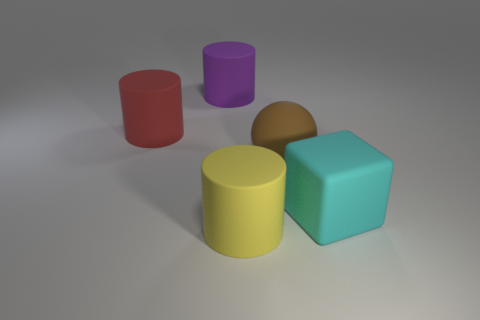The large thing that is on the right side of the large purple rubber cylinder and on the left side of the large brown rubber ball has what shape?
Make the answer very short. Cylinder. What number of large cyan blocks have the same material as the brown ball?
Make the answer very short. 1. Are there fewer things that are right of the sphere than big purple objects that are on the right side of the block?
Provide a succinct answer. No. There is a cylinder that is to the right of the rubber cylinder that is behind the red cylinder behind the cyan rubber block; what is it made of?
Your response must be concise. Rubber. There is a rubber thing that is both in front of the big matte ball and on the right side of the big yellow matte cylinder; what is its size?
Your answer should be compact. Large. How many cubes are either brown metallic things or big yellow matte objects?
Offer a terse response. 0. The matte cube that is the same size as the red rubber cylinder is what color?
Your answer should be compact. Cyan. Are there any other things that have the same shape as the cyan thing?
Provide a short and direct response. No. What number of objects are either big yellow objects or matte things that are behind the big cyan object?
Your answer should be very brief. 4. Is the number of big matte objects that are in front of the yellow matte cylinder less than the number of small blue rubber cylinders?
Make the answer very short. No. 